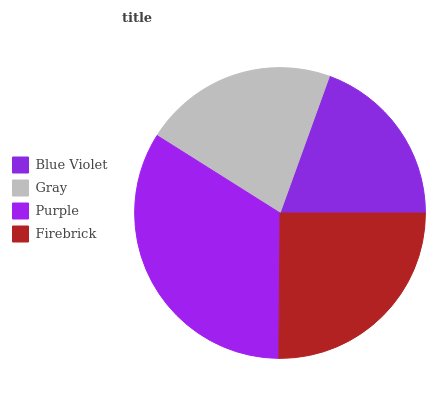Is Blue Violet the minimum?
Answer yes or no. Yes. Is Purple the maximum?
Answer yes or no. Yes. Is Gray the minimum?
Answer yes or no. No. Is Gray the maximum?
Answer yes or no. No. Is Gray greater than Blue Violet?
Answer yes or no. Yes. Is Blue Violet less than Gray?
Answer yes or no. Yes. Is Blue Violet greater than Gray?
Answer yes or no. No. Is Gray less than Blue Violet?
Answer yes or no. No. Is Firebrick the high median?
Answer yes or no. Yes. Is Gray the low median?
Answer yes or no. Yes. Is Gray the high median?
Answer yes or no. No. Is Firebrick the low median?
Answer yes or no. No. 